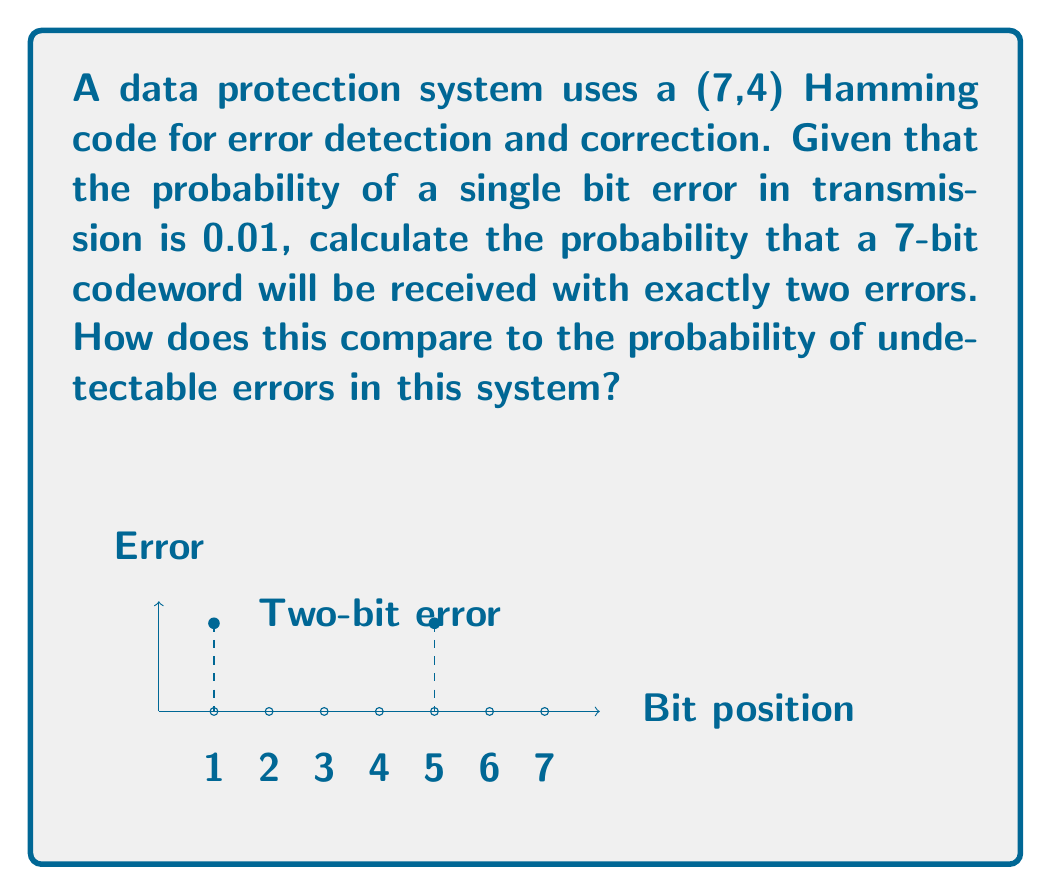Can you solve this math problem? Let's approach this step-by-step:

1) First, we need to calculate the probability of exactly two errors in a 7-bit codeword.

2) This follows a binomial distribution. The probability of exactly k successes in n trials is given by:

   $$P(X = k) = \binom{n}{k} p^k (1-p)^{n-k}$$

   where $n$ is the number of trials, $k$ is the number of successes, $p$ is the probability of success on a single trial.

3) In our case:
   $n = 7$ (7-bit codeword)
   $k = 2$ (exactly two errors)
   $p = 0.01$ (probability of error for a single bit)

4) Plugging these into the formula:

   $$P(X = 2) = \binom{7}{2} (0.01)^2 (0.99)^5$$

5) Calculate $\binom{7}{2}$:
   $$\binom{7}{2} = \frac{7!}{2!(7-2)!} = \frac{7 * 6}{2 * 1} = 21$$

6) Now we can compute:

   $$P(X = 2) = 21 * (0.01)^2 * (0.99)^5 = 21 * 0.0001 * 0.9510 \approx 0.001996$$

7) For the second part of the question, we need to consider undetectable errors. In a (7,4) Hamming code, all single-bit errors are detectable and correctable, and all double-bit errors are detectable. Only triple-bit errors or more can be undetectable.

8) The probability of 3 or more errors is:

   $$P(X \geq 3) = 1 - P(X = 0) - P(X = 1) - P(X = 2)$$

9) We've already calculated $P(X = 2)$. Similarly:

   $$P(X = 0) = \binom{7}{0} (0.99)^7 \approx 0.9322$$
   $$P(X = 1) = \binom{7}{1} (0.01)(0.99)^6 \approx 0.0659$$

10) Therefore:

    $$P(X \geq 3) = 1 - 0.9322 - 0.0659 - 0.001996 \approx 0.000004$$

11) The probability of undetectable errors (0.000004) is much lower than the probability of exactly two errors (0.001996).
Answer: $P(\text{two errors}) \approx 0.001996$; $P(\text{undetectable errors}) \approx 0.000004$ 